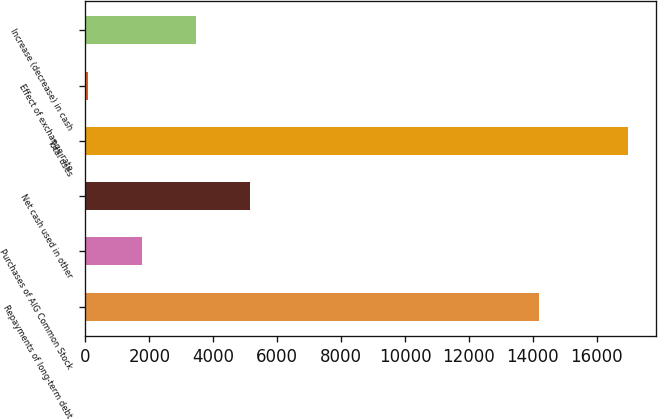<chart> <loc_0><loc_0><loc_500><loc_500><bar_chart><fcel>Repayments of long-term debt<fcel>Purchases of AIG Common Stock<fcel>Net cash used in other<fcel>Total uses<fcel>Effect of exchange rate<fcel>Increase (decrease) in cash<nl><fcel>14197<fcel>1782.1<fcel>5162.3<fcel>16993<fcel>92<fcel>3472.2<nl></chart> 